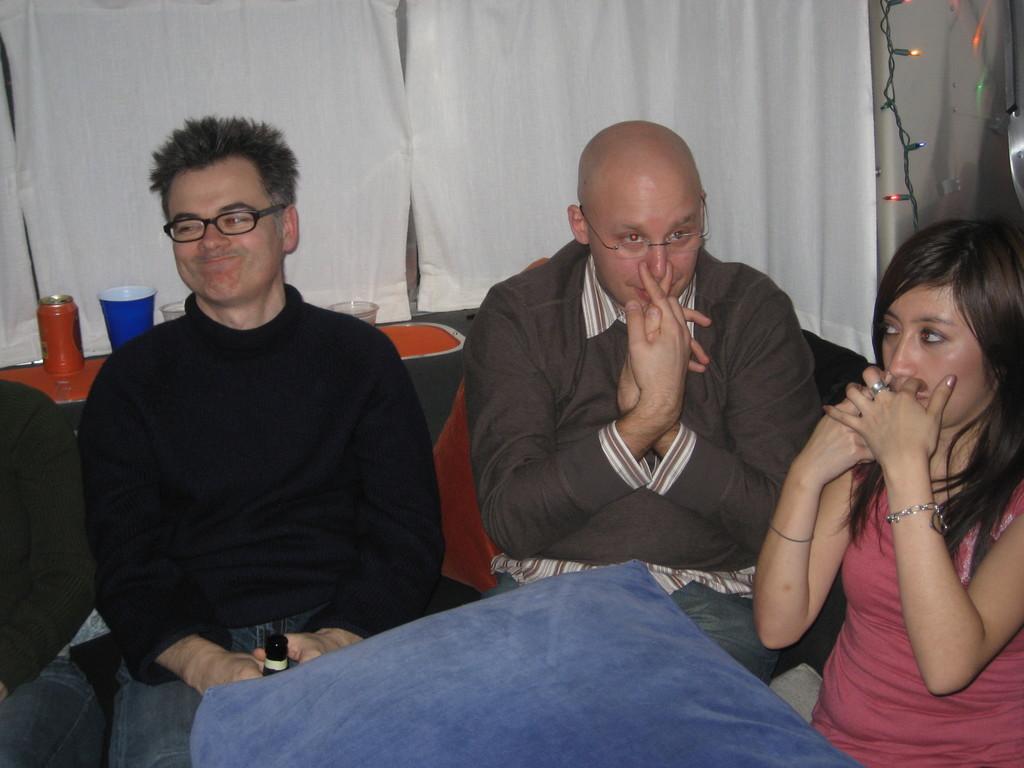In one or two sentences, can you explain what this image depicts? This picture shows few people seated and couple of them holding their nose with their hands and we see couple of them wore spectacles on their faces and we see I can and few glasses on the table and we see curtains and lighting and we see a man holding a bottle in his hand and we see a woman seated on the side and a cushion. 